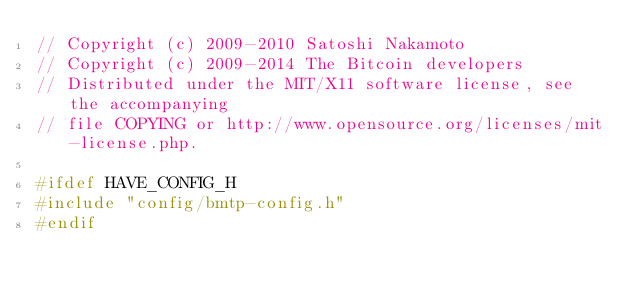<code> <loc_0><loc_0><loc_500><loc_500><_C++_>// Copyright (c) 2009-2010 Satoshi Nakamoto
// Copyright (c) 2009-2014 The Bitcoin developers
// Distributed under the MIT/X11 software license, see the accompanying
// file COPYING or http://www.opensource.org/licenses/mit-license.php.

#ifdef HAVE_CONFIG_H
#include "config/bmtp-config.h"
#endif
</code> 